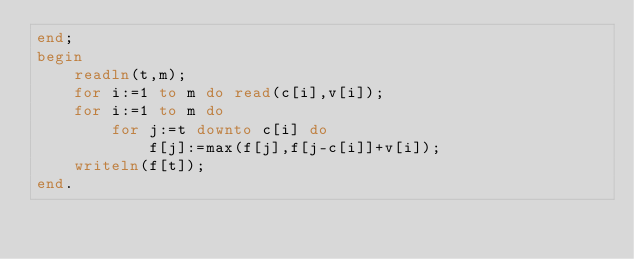Convert code to text. <code><loc_0><loc_0><loc_500><loc_500><_Pascal_>end;
begin
    readln(t,m);
    for i:=1 to m do read(c[i],v[i]);
    for i:=1 to m do
        for j:=t downto c[i] do
            f[j]:=max(f[j],f[j-c[i]]+v[i]);
    writeln(f[t]);
end.</code> 